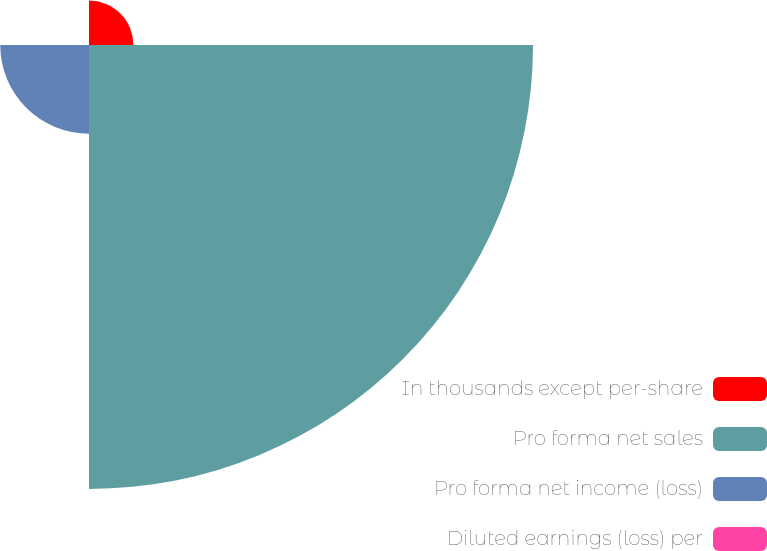<chart> <loc_0><loc_0><loc_500><loc_500><pie_chart><fcel>In thousands except per-share<fcel>Pro forma net sales<fcel>Pro forma net income (loss)<fcel>Diluted earnings (loss) per<nl><fcel>7.69%<fcel>76.92%<fcel>15.38%<fcel>0.0%<nl></chart> 